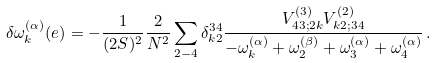<formula> <loc_0><loc_0><loc_500><loc_500>\delta \omega ^ { ( \alpha ) } _ { k } ( e ) = - \frac { 1 } { ( 2 S ) ^ { 2 } } \frac { 2 } { N ^ { 2 } } \sum _ { 2 - 4 } \delta _ { k 2 } ^ { 3 4 } \frac { V ^ { ( 3 ) } _ { 4 3 ; 2 k } V ^ { ( 2 ) } _ { k 2 ; 3 4 } } { - \omega ^ { ( \alpha ) } _ { k } + \omega ^ { ( \beta ) } _ { 2 } + \omega ^ { ( \alpha ) } _ { 3 } + \omega ^ { ( \alpha ) } _ { 4 } } \, .</formula> 